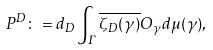Convert formula to latex. <formula><loc_0><loc_0><loc_500><loc_500>P ^ { D } \colon = d _ { D } \int _ { \Gamma } \overline { \zeta _ { D } ( \gamma ) } O _ { \gamma } d \mu ( \gamma ) ,</formula> 